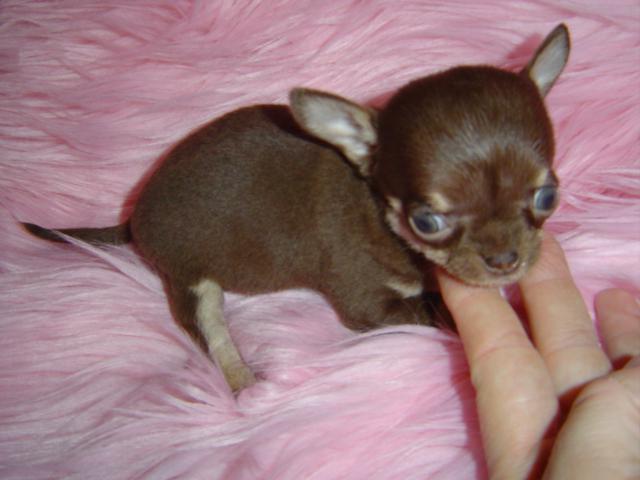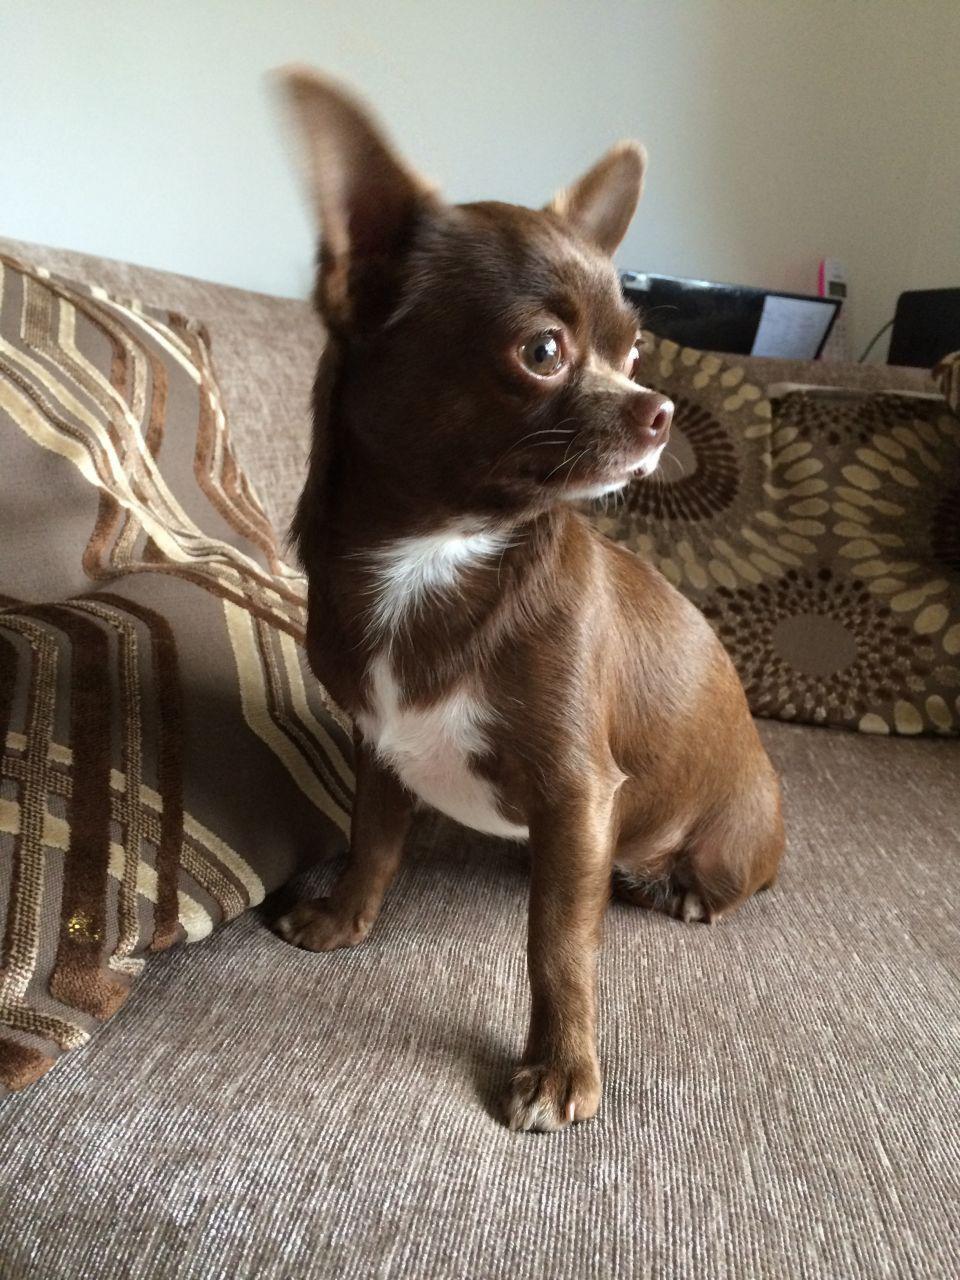The first image is the image on the left, the second image is the image on the right. Analyze the images presented: Is the assertion "A human hand is touching a small dog in one image." valid? Answer yes or no. Yes. The first image is the image on the left, the second image is the image on the right. Evaluate the accuracy of this statement regarding the images: "There are two chihuahua puppies". Is it true? Answer yes or no. Yes. 